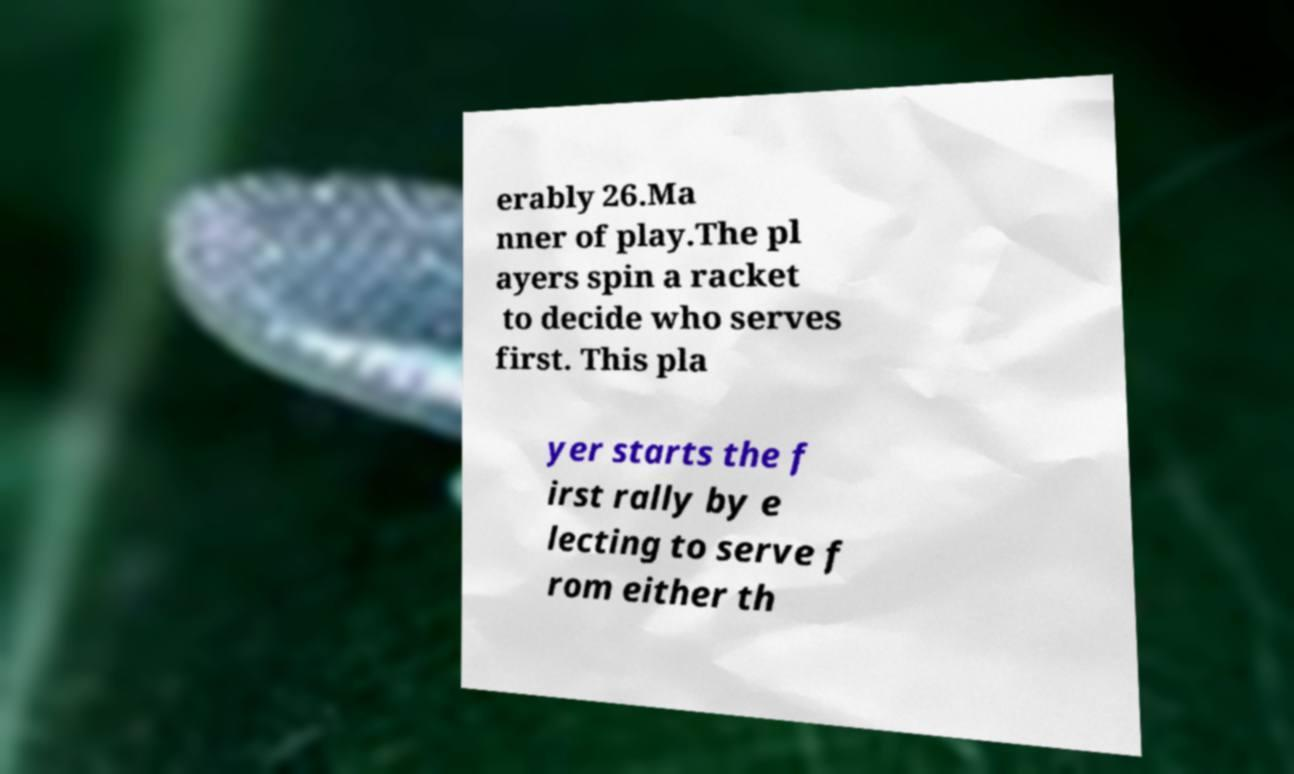I need the written content from this picture converted into text. Can you do that? erably 26.Ma nner of play.The pl ayers spin a racket to decide who serves first. This pla yer starts the f irst rally by e lecting to serve f rom either th 